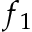Convert formula to latex. <formula><loc_0><loc_0><loc_500><loc_500>f _ { 1 }</formula> 